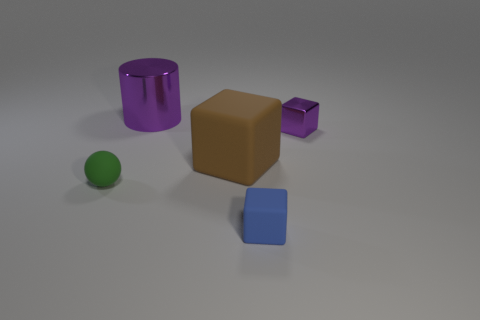Do the tiny thing that is in front of the ball and the green sphere have the same material?
Give a very brief answer. Yes. What color is the matte object that is left of the blue matte block and right of the small green thing?
Keep it short and to the point. Brown. There is a small block that is in front of the tiny green thing; what number of tiny green balls are in front of it?
Your response must be concise. 0. What material is the other brown object that is the same shape as the small metal thing?
Give a very brief answer. Rubber. What color is the tiny ball?
Keep it short and to the point. Green. What number of objects are either large rubber objects or tiny gray cylinders?
Ensure brevity in your answer.  1. There is a tiny matte thing that is right of the metallic thing that is to the left of the small purple metallic thing; what is its shape?
Keep it short and to the point. Cube. How many other things are made of the same material as the big block?
Your answer should be very brief. 2. Are the green sphere and the purple thing that is behind the small purple metallic thing made of the same material?
Your answer should be compact. No. How many things are small matte objects that are in front of the ball or tiny blocks that are behind the small green rubber ball?
Provide a succinct answer. 2. 